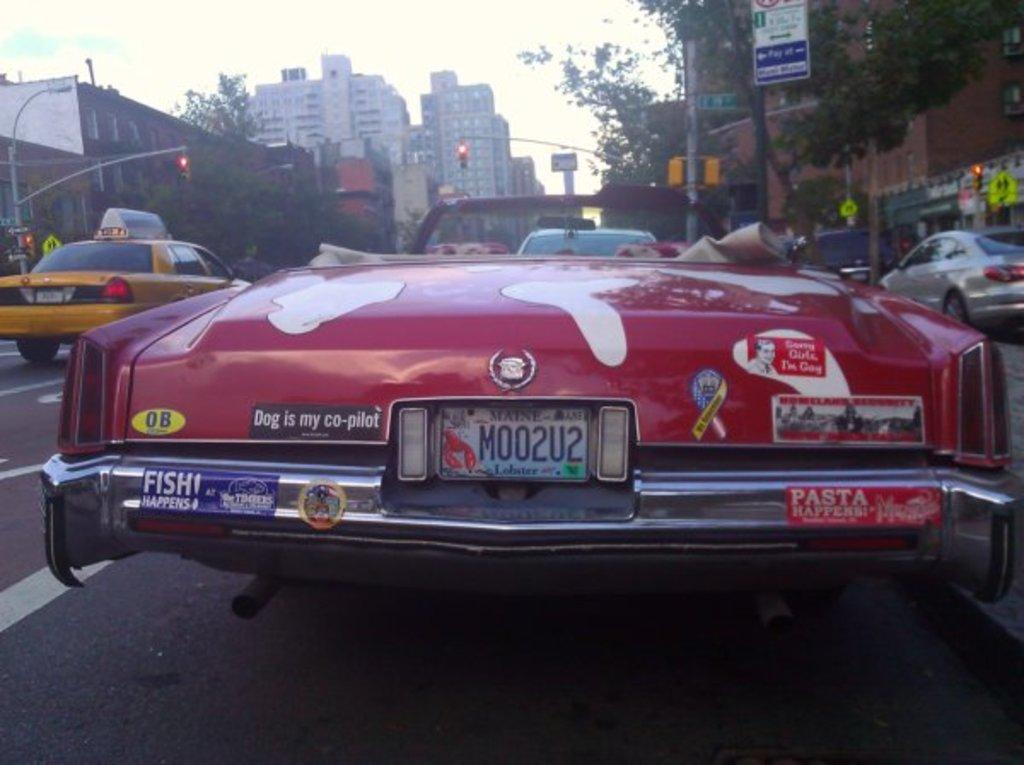<image>
Provide a brief description of the given image. A red convertible is parked on the side of the road and has lots of bumper stickers including one that says Dog is my co-pilot. 